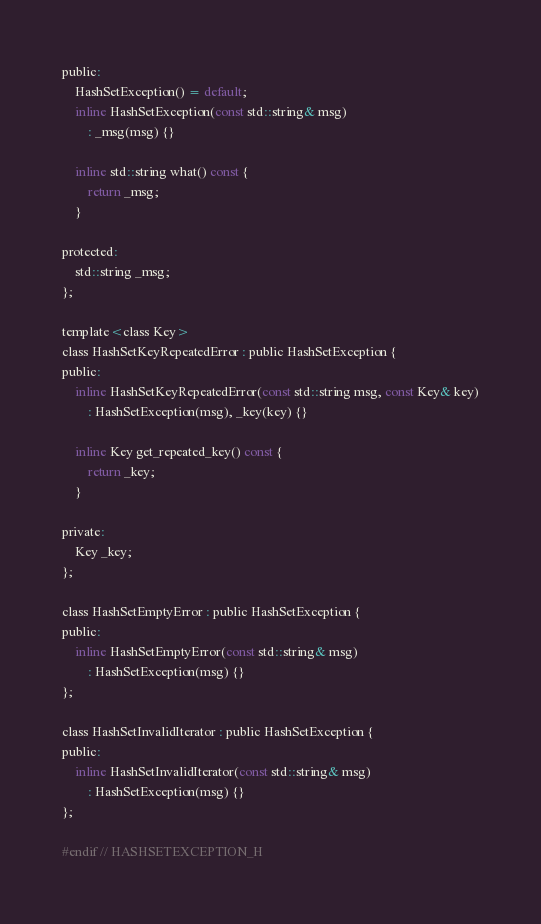<code> <loc_0><loc_0><loc_500><loc_500><_C_>public:
    HashSetException() = default;
    inline HashSetException(const std::string& msg)
        : _msg(msg) {}

    inline std::string what() const {
        return _msg;
    }

protected:
    std::string _msg;
};

template<class Key>
class HashSetKeyRepeatedError : public HashSetException {
public:
    inline HashSetKeyRepeatedError(const std::string msg, const Key& key)
        : HashSetException(msg), _key(key) {}

    inline Key get_repeated_key() const {
        return _key;
    }

private:
    Key _key;
};

class HashSetEmptyError : public HashSetException {
public:
    inline HashSetEmptyError(const std::string& msg)
        : HashSetException(msg) {}
};

class HashSetInvalidIterator : public HashSetException {
public:
    inline HashSetInvalidIterator(const std::string& msg)
        : HashSetException(msg) {}
};

#endif // HASHSETEXCEPTION_H
</code> 